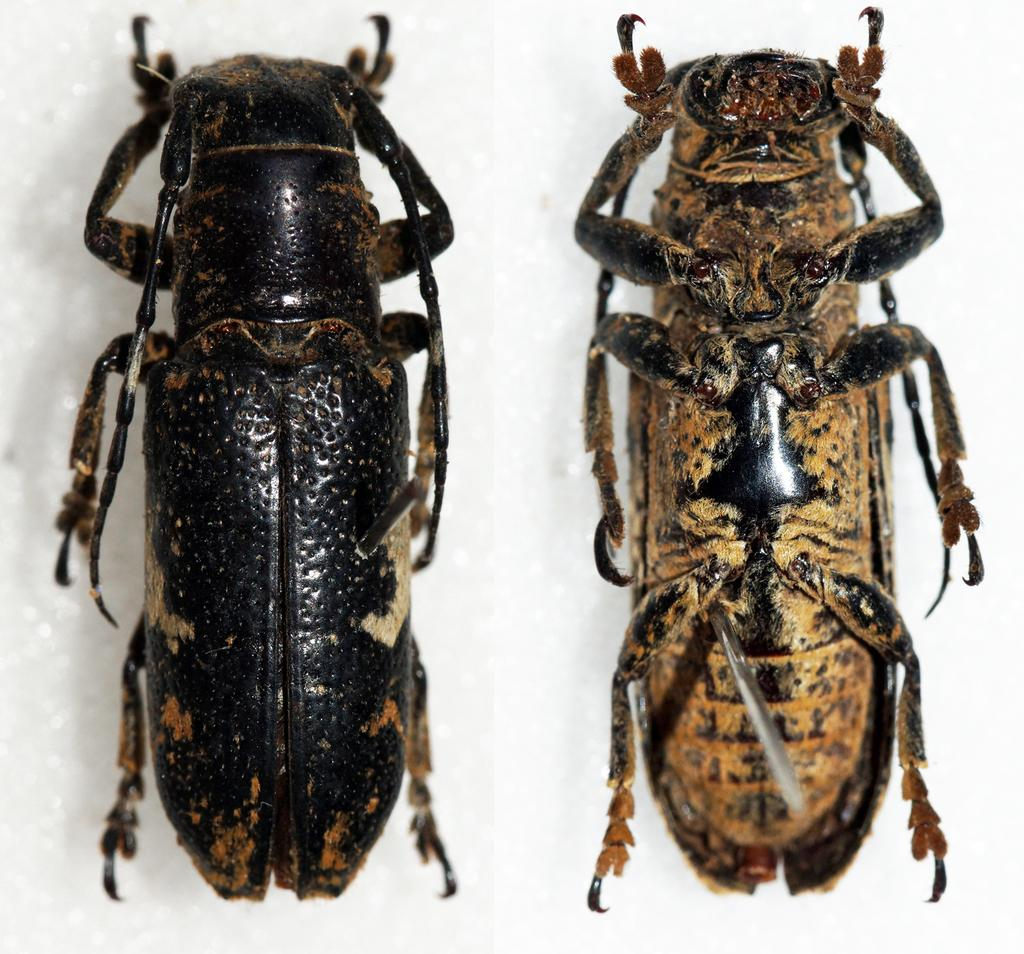How many insects are present in the image? There are two insects in the image. What is the color of the surface where the insects are located? The insects are on a white surface. What team do the insects belong to in the image? The insects do not belong to any team in the image, as insects are not involved in team sports. 